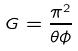<formula> <loc_0><loc_0><loc_500><loc_500>G = \frac { \pi ^ { 2 } } { \theta \phi }</formula> 